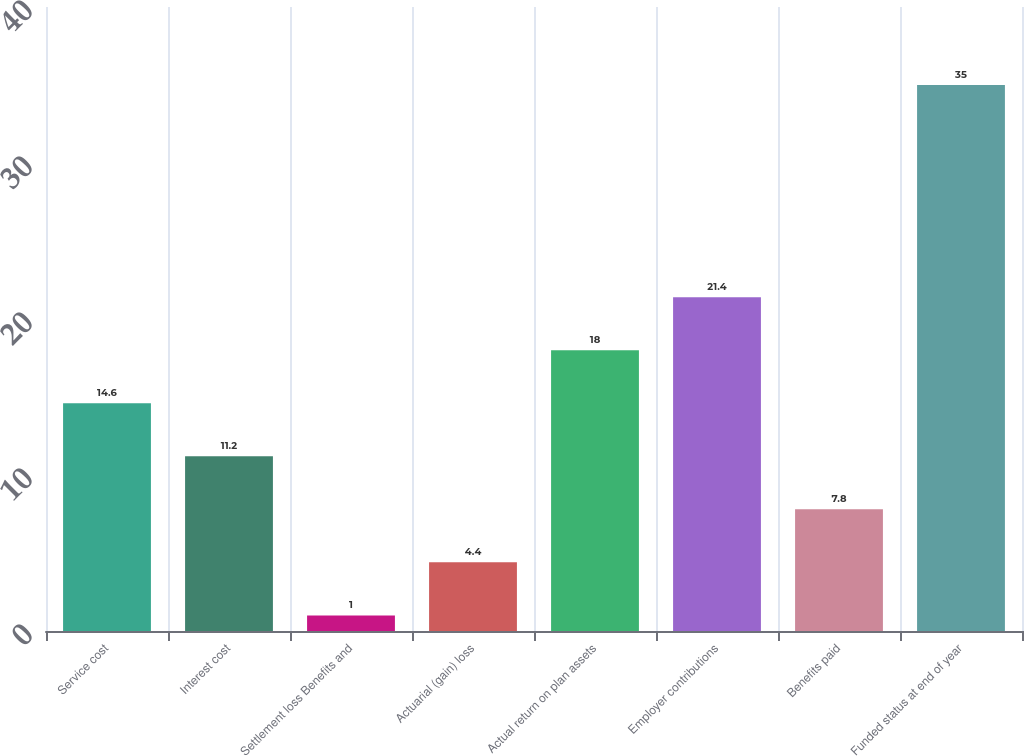Convert chart to OTSL. <chart><loc_0><loc_0><loc_500><loc_500><bar_chart><fcel>Service cost<fcel>Interest cost<fcel>Settlement loss Benefits and<fcel>Actuarial (gain) loss<fcel>Actual return on plan assets<fcel>Employer contributions<fcel>Benefits paid<fcel>Funded status at end of year<nl><fcel>14.6<fcel>11.2<fcel>1<fcel>4.4<fcel>18<fcel>21.4<fcel>7.8<fcel>35<nl></chart> 